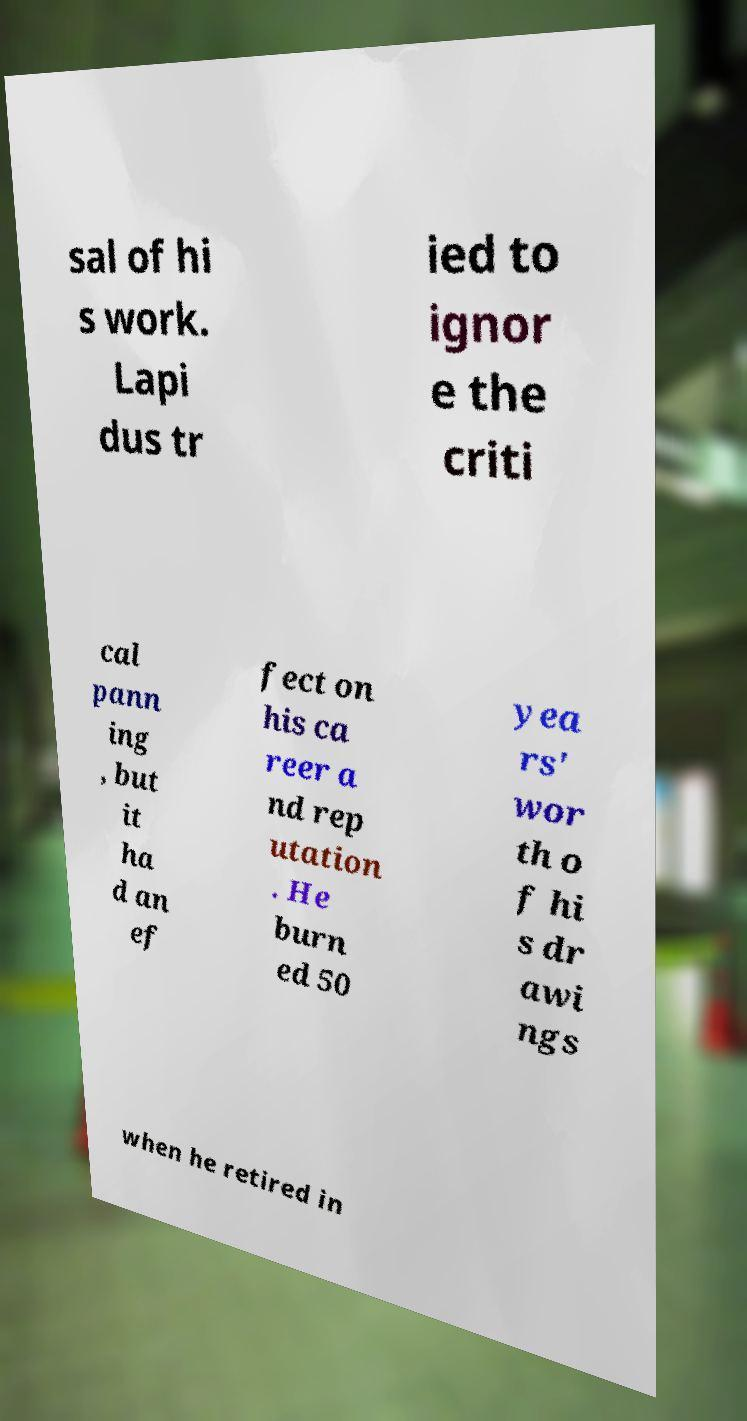For documentation purposes, I need the text within this image transcribed. Could you provide that? sal of hi s work. Lapi dus tr ied to ignor e the criti cal pann ing , but it ha d an ef fect on his ca reer a nd rep utation . He burn ed 50 yea rs' wor th o f hi s dr awi ngs when he retired in 